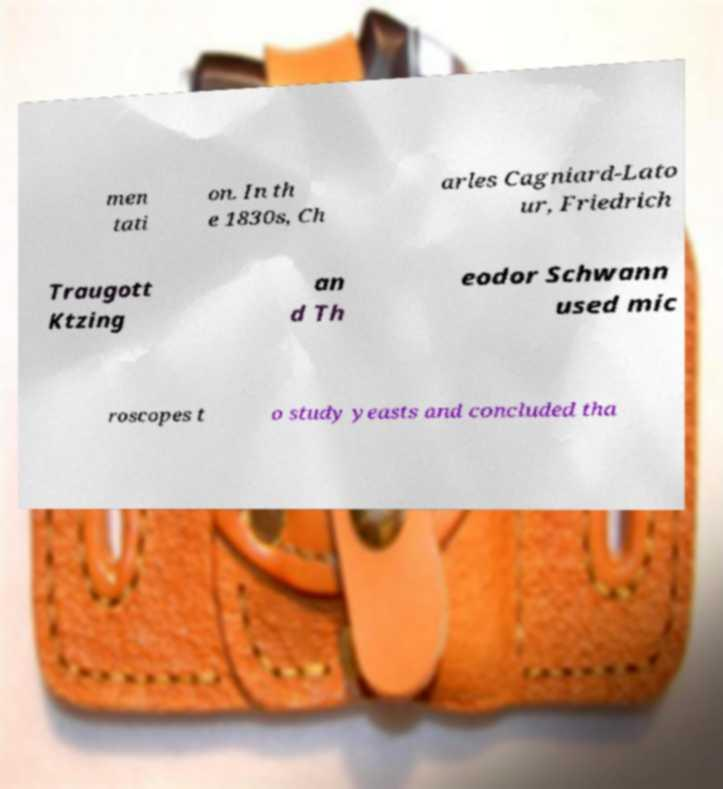There's text embedded in this image that I need extracted. Can you transcribe it verbatim? men tati on. In th e 1830s, Ch arles Cagniard-Lato ur, Friedrich Traugott Ktzing an d Th eodor Schwann used mic roscopes t o study yeasts and concluded tha 